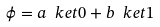Convert formula to latex. <formula><loc_0><loc_0><loc_500><loc_500>\phi = a \ k e t 0 + b \ k e t 1</formula> 